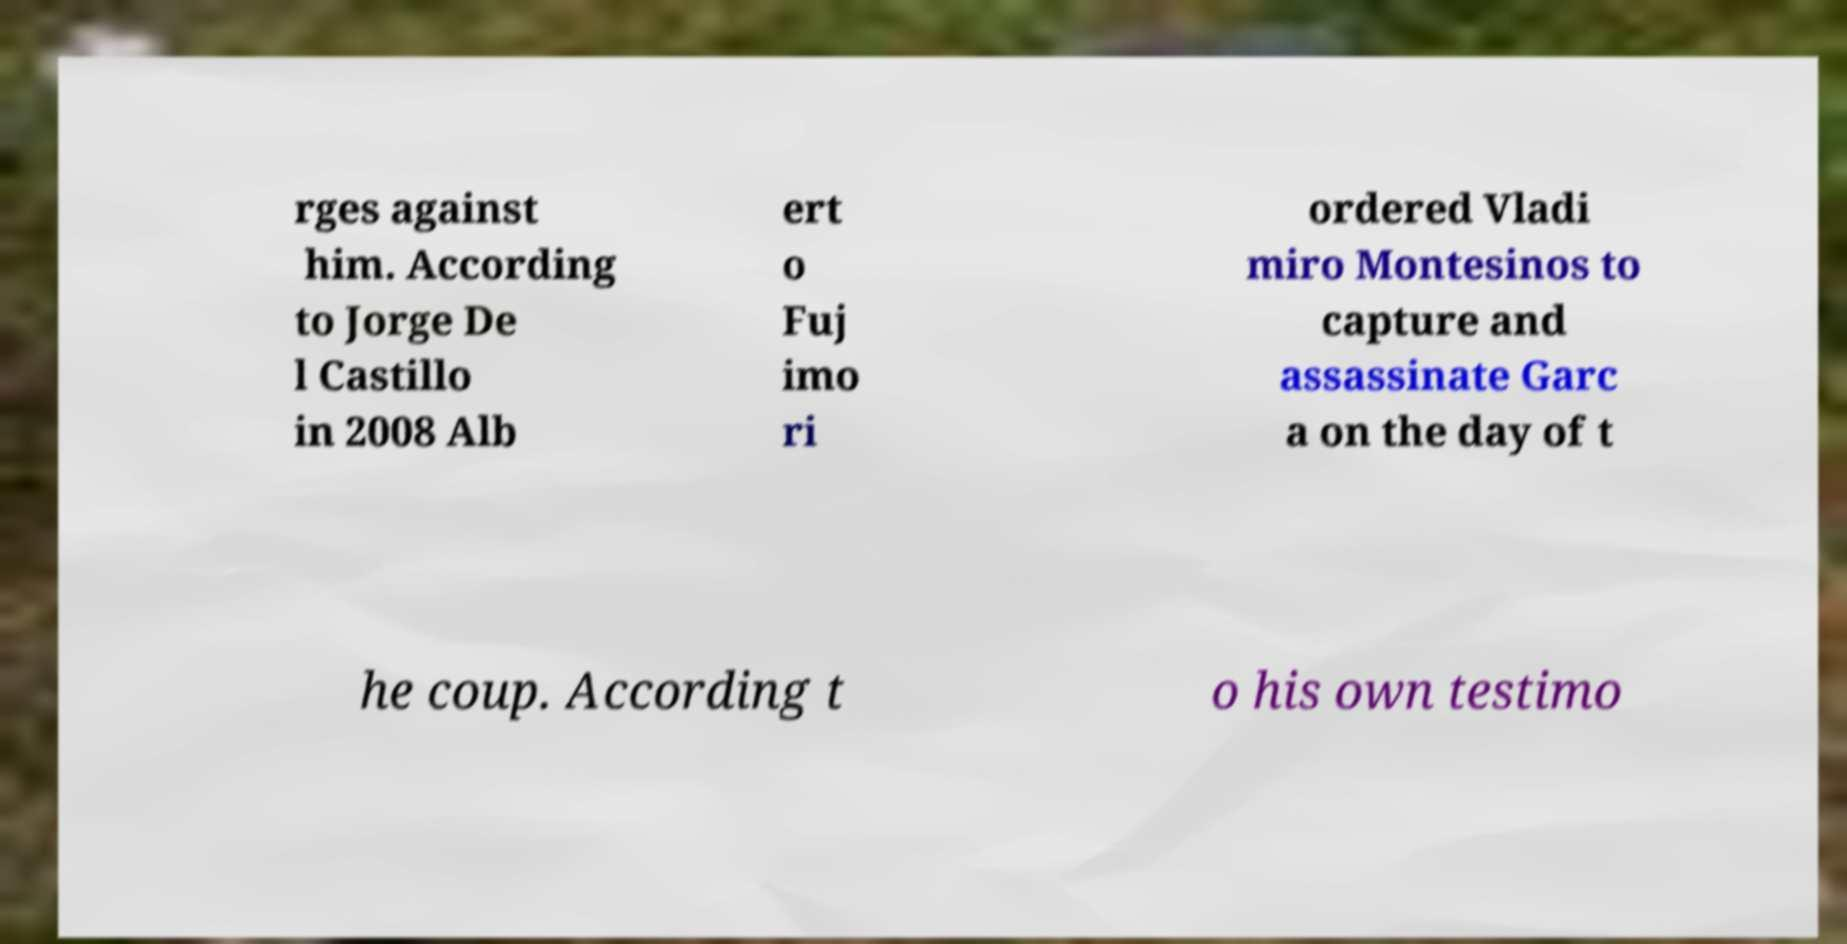Please read and relay the text visible in this image. What does it say? rges against him. According to Jorge De l Castillo in 2008 Alb ert o Fuj imo ri ordered Vladi miro Montesinos to capture and assassinate Garc a on the day of t he coup. According t o his own testimo 